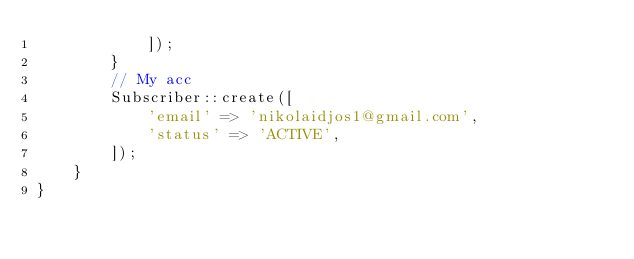Convert code to text. <code><loc_0><loc_0><loc_500><loc_500><_PHP_>            ]);
        }
        // My acc
        Subscriber::create([
            'email' => 'nikolaidjos1@gmail.com',
            'status' => 'ACTIVE',
        ]);
    }
}
</code> 